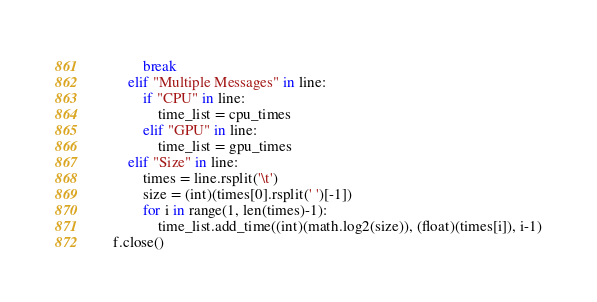Convert code to text. <code><loc_0><loc_0><loc_500><loc_500><_Python_>            break
        elif "Multiple Messages" in line:
            if "CPU" in line:
                time_list = cpu_times
            elif "GPU" in line:
                time_list = gpu_times
        elif "Size" in line:
            times = line.rsplit('\t')
            size = (int)(times[0].rsplit(' ')[-1])
            for i in range(1, len(times)-1):
                time_list.add_time((int)(math.log2(size)), (float)(times[i]), i-1)
    f.close()



</code> 